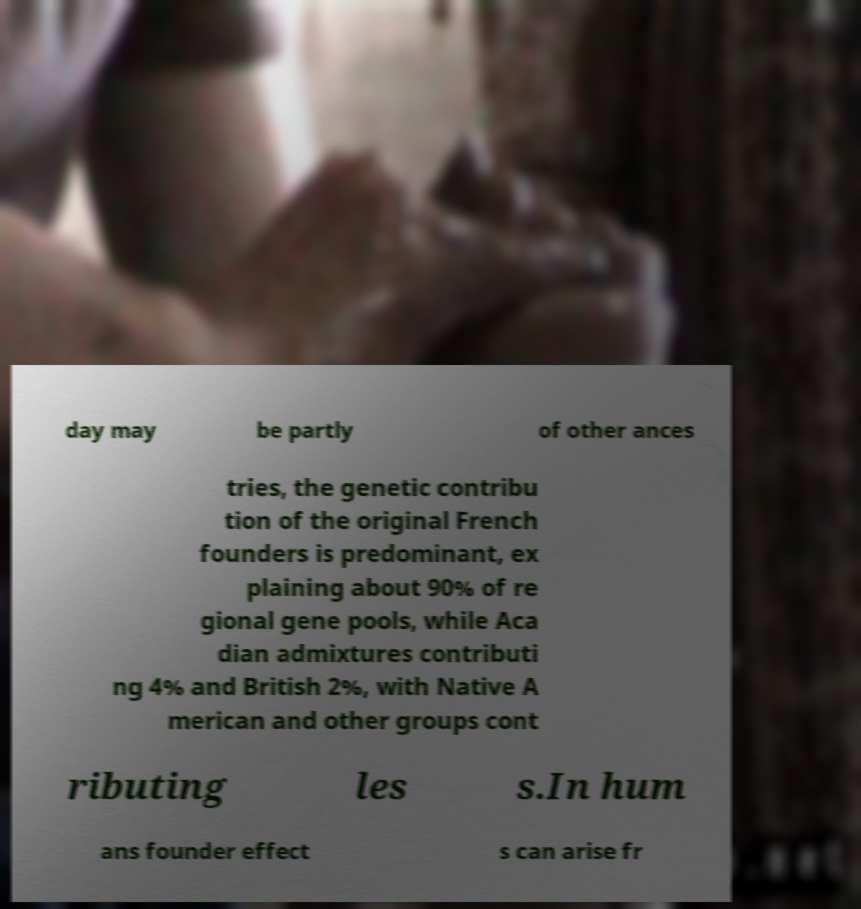Please read and relay the text visible in this image. What does it say? day may be partly of other ances tries, the genetic contribu tion of the original French founders is predominant, ex plaining about 90% of re gional gene pools, while Aca dian admixtures contributi ng 4% and British 2%, with Native A merican and other groups cont ributing les s.In hum ans founder effect s can arise fr 